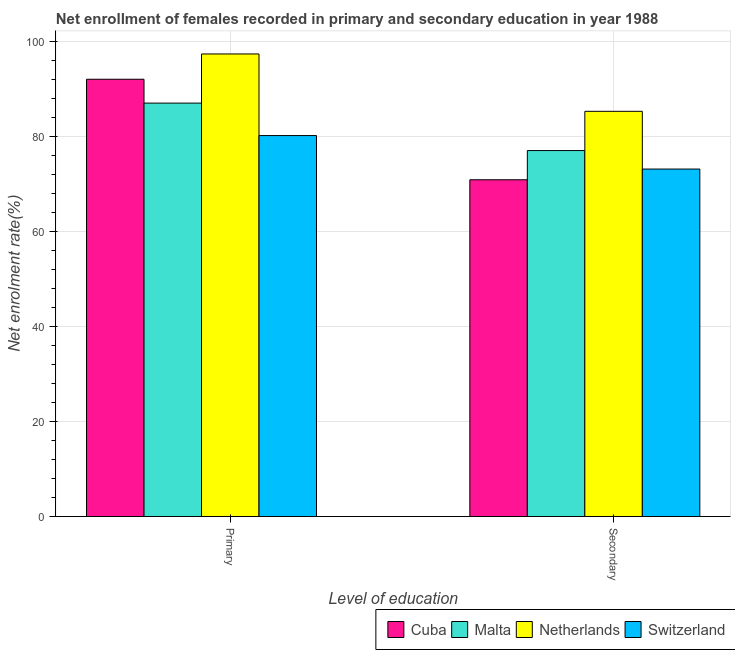How many groups of bars are there?
Make the answer very short. 2. Are the number of bars per tick equal to the number of legend labels?
Your response must be concise. Yes. What is the label of the 2nd group of bars from the left?
Offer a terse response. Secondary. What is the enrollment rate in secondary education in Malta?
Offer a terse response. 77.09. Across all countries, what is the maximum enrollment rate in secondary education?
Give a very brief answer. 85.35. Across all countries, what is the minimum enrollment rate in secondary education?
Your answer should be very brief. 70.93. In which country was the enrollment rate in primary education minimum?
Your answer should be compact. Switzerland. What is the total enrollment rate in secondary education in the graph?
Keep it short and to the point. 306.56. What is the difference between the enrollment rate in secondary education in Malta and that in Netherlands?
Your answer should be compact. -8.26. What is the difference between the enrollment rate in secondary education in Switzerland and the enrollment rate in primary education in Cuba?
Your response must be concise. -18.92. What is the average enrollment rate in primary education per country?
Offer a terse response. 89.22. What is the difference between the enrollment rate in primary education and enrollment rate in secondary education in Switzerland?
Make the answer very short. 7.05. What is the ratio of the enrollment rate in primary education in Cuba to that in Netherlands?
Ensure brevity in your answer.  0.95. Is the enrollment rate in primary education in Switzerland less than that in Malta?
Keep it short and to the point. Yes. What does the 2nd bar from the left in Secondary represents?
Offer a very short reply. Malta. What does the 4th bar from the right in Secondary represents?
Your answer should be compact. Cuba. How many countries are there in the graph?
Your answer should be very brief. 4. Are the values on the major ticks of Y-axis written in scientific E-notation?
Keep it short and to the point. No. Does the graph contain any zero values?
Your answer should be compact. No. How many legend labels are there?
Offer a very short reply. 4. What is the title of the graph?
Offer a very short reply. Net enrollment of females recorded in primary and secondary education in year 1988. Does "Djibouti" appear as one of the legend labels in the graph?
Provide a short and direct response. No. What is the label or title of the X-axis?
Keep it short and to the point. Level of education. What is the label or title of the Y-axis?
Provide a short and direct response. Net enrolment rate(%). What is the Net enrolment rate(%) in Cuba in Primary?
Your answer should be very brief. 92.11. What is the Net enrolment rate(%) of Malta in Primary?
Offer a very short reply. 87.08. What is the Net enrolment rate(%) in Netherlands in Primary?
Provide a short and direct response. 97.44. What is the Net enrolment rate(%) in Switzerland in Primary?
Provide a short and direct response. 80.24. What is the Net enrolment rate(%) in Cuba in Secondary?
Your answer should be very brief. 70.93. What is the Net enrolment rate(%) of Malta in Secondary?
Keep it short and to the point. 77.09. What is the Net enrolment rate(%) of Netherlands in Secondary?
Offer a terse response. 85.35. What is the Net enrolment rate(%) of Switzerland in Secondary?
Offer a terse response. 73.19. Across all Level of education, what is the maximum Net enrolment rate(%) in Cuba?
Your response must be concise. 92.11. Across all Level of education, what is the maximum Net enrolment rate(%) of Malta?
Your answer should be very brief. 87.08. Across all Level of education, what is the maximum Net enrolment rate(%) in Netherlands?
Your answer should be compact. 97.44. Across all Level of education, what is the maximum Net enrolment rate(%) of Switzerland?
Your answer should be compact. 80.24. Across all Level of education, what is the minimum Net enrolment rate(%) of Cuba?
Make the answer very short. 70.93. Across all Level of education, what is the minimum Net enrolment rate(%) of Malta?
Your response must be concise. 77.09. Across all Level of education, what is the minimum Net enrolment rate(%) in Netherlands?
Your response must be concise. 85.35. Across all Level of education, what is the minimum Net enrolment rate(%) of Switzerland?
Provide a succinct answer. 73.19. What is the total Net enrolment rate(%) in Cuba in the graph?
Provide a short and direct response. 163.04. What is the total Net enrolment rate(%) of Malta in the graph?
Ensure brevity in your answer.  164.17. What is the total Net enrolment rate(%) of Netherlands in the graph?
Offer a terse response. 182.79. What is the total Net enrolment rate(%) of Switzerland in the graph?
Provide a short and direct response. 153.44. What is the difference between the Net enrolment rate(%) in Cuba in Primary and that in Secondary?
Provide a short and direct response. 21.18. What is the difference between the Net enrolment rate(%) of Malta in Primary and that in Secondary?
Provide a succinct answer. 10. What is the difference between the Net enrolment rate(%) of Netherlands in Primary and that in Secondary?
Provide a short and direct response. 12.09. What is the difference between the Net enrolment rate(%) in Switzerland in Primary and that in Secondary?
Offer a very short reply. 7.05. What is the difference between the Net enrolment rate(%) of Cuba in Primary and the Net enrolment rate(%) of Malta in Secondary?
Give a very brief answer. 15.02. What is the difference between the Net enrolment rate(%) in Cuba in Primary and the Net enrolment rate(%) in Netherlands in Secondary?
Ensure brevity in your answer.  6.76. What is the difference between the Net enrolment rate(%) of Cuba in Primary and the Net enrolment rate(%) of Switzerland in Secondary?
Provide a short and direct response. 18.92. What is the difference between the Net enrolment rate(%) of Malta in Primary and the Net enrolment rate(%) of Netherlands in Secondary?
Ensure brevity in your answer.  1.73. What is the difference between the Net enrolment rate(%) of Malta in Primary and the Net enrolment rate(%) of Switzerland in Secondary?
Ensure brevity in your answer.  13.89. What is the difference between the Net enrolment rate(%) in Netherlands in Primary and the Net enrolment rate(%) in Switzerland in Secondary?
Your answer should be very brief. 24.24. What is the average Net enrolment rate(%) in Cuba per Level of education?
Offer a very short reply. 81.52. What is the average Net enrolment rate(%) in Malta per Level of education?
Offer a terse response. 82.08. What is the average Net enrolment rate(%) in Netherlands per Level of education?
Make the answer very short. 91.39. What is the average Net enrolment rate(%) of Switzerland per Level of education?
Keep it short and to the point. 76.72. What is the difference between the Net enrolment rate(%) of Cuba and Net enrolment rate(%) of Malta in Primary?
Provide a short and direct response. 5.02. What is the difference between the Net enrolment rate(%) of Cuba and Net enrolment rate(%) of Netherlands in Primary?
Offer a very short reply. -5.33. What is the difference between the Net enrolment rate(%) of Cuba and Net enrolment rate(%) of Switzerland in Primary?
Your answer should be very brief. 11.86. What is the difference between the Net enrolment rate(%) in Malta and Net enrolment rate(%) in Netherlands in Primary?
Give a very brief answer. -10.35. What is the difference between the Net enrolment rate(%) in Malta and Net enrolment rate(%) in Switzerland in Primary?
Your answer should be very brief. 6.84. What is the difference between the Net enrolment rate(%) of Netherlands and Net enrolment rate(%) of Switzerland in Primary?
Give a very brief answer. 17.19. What is the difference between the Net enrolment rate(%) of Cuba and Net enrolment rate(%) of Malta in Secondary?
Keep it short and to the point. -6.15. What is the difference between the Net enrolment rate(%) of Cuba and Net enrolment rate(%) of Netherlands in Secondary?
Provide a short and direct response. -14.42. What is the difference between the Net enrolment rate(%) in Cuba and Net enrolment rate(%) in Switzerland in Secondary?
Provide a short and direct response. -2.26. What is the difference between the Net enrolment rate(%) of Malta and Net enrolment rate(%) of Netherlands in Secondary?
Provide a short and direct response. -8.26. What is the difference between the Net enrolment rate(%) in Malta and Net enrolment rate(%) in Switzerland in Secondary?
Give a very brief answer. 3.89. What is the difference between the Net enrolment rate(%) in Netherlands and Net enrolment rate(%) in Switzerland in Secondary?
Offer a terse response. 12.16. What is the ratio of the Net enrolment rate(%) of Cuba in Primary to that in Secondary?
Ensure brevity in your answer.  1.3. What is the ratio of the Net enrolment rate(%) of Malta in Primary to that in Secondary?
Your answer should be compact. 1.13. What is the ratio of the Net enrolment rate(%) in Netherlands in Primary to that in Secondary?
Provide a short and direct response. 1.14. What is the ratio of the Net enrolment rate(%) of Switzerland in Primary to that in Secondary?
Give a very brief answer. 1.1. What is the difference between the highest and the second highest Net enrolment rate(%) of Cuba?
Ensure brevity in your answer.  21.18. What is the difference between the highest and the second highest Net enrolment rate(%) in Malta?
Your answer should be compact. 10. What is the difference between the highest and the second highest Net enrolment rate(%) in Netherlands?
Ensure brevity in your answer.  12.09. What is the difference between the highest and the second highest Net enrolment rate(%) in Switzerland?
Your answer should be very brief. 7.05. What is the difference between the highest and the lowest Net enrolment rate(%) of Cuba?
Ensure brevity in your answer.  21.18. What is the difference between the highest and the lowest Net enrolment rate(%) of Malta?
Provide a short and direct response. 10. What is the difference between the highest and the lowest Net enrolment rate(%) of Netherlands?
Provide a succinct answer. 12.09. What is the difference between the highest and the lowest Net enrolment rate(%) in Switzerland?
Provide a succinct answer. 7.05. 